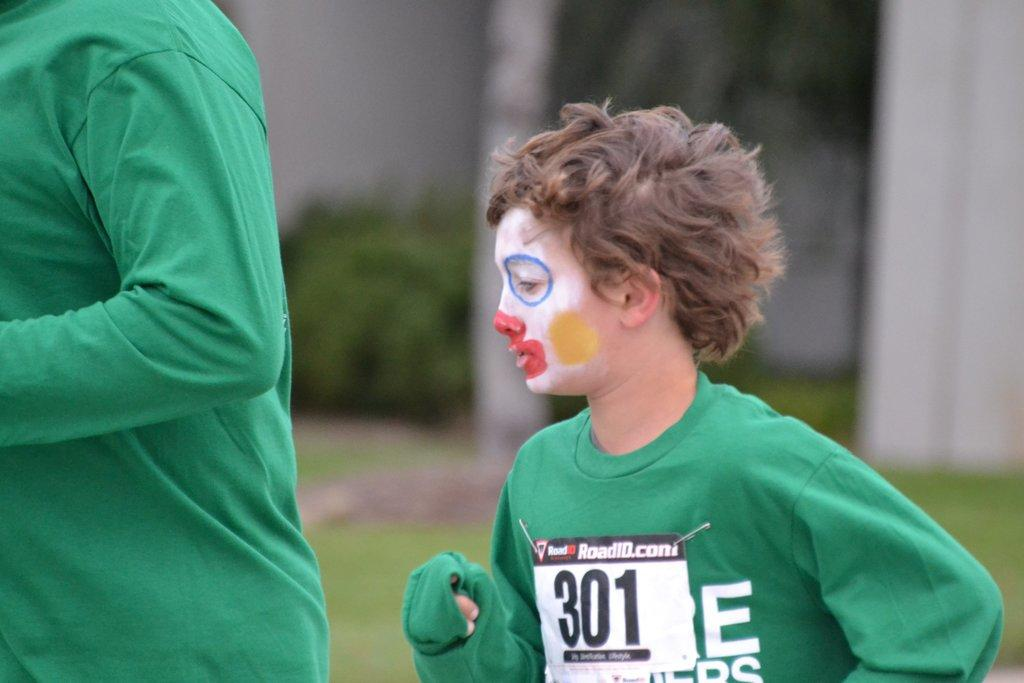What is the main subject of the image? The main subject of the image is a child. What can be seen on the child's clothing? The child is wearing a chess number. What is a noticeable feature on the child's face? The child has painting on their face. Can you describe the person near the child? There is another person near the child, but their specific features are not mentioned in the facts. How would you describe the background of the image? The background of the image is blurred. What type of cherry is being used as a prop in the image? There is no cherry present in the image. How does the rain affect the child's clothing in the image? There is no mention of rain in the image, so we cannot determine its effect on the child's clothing. 